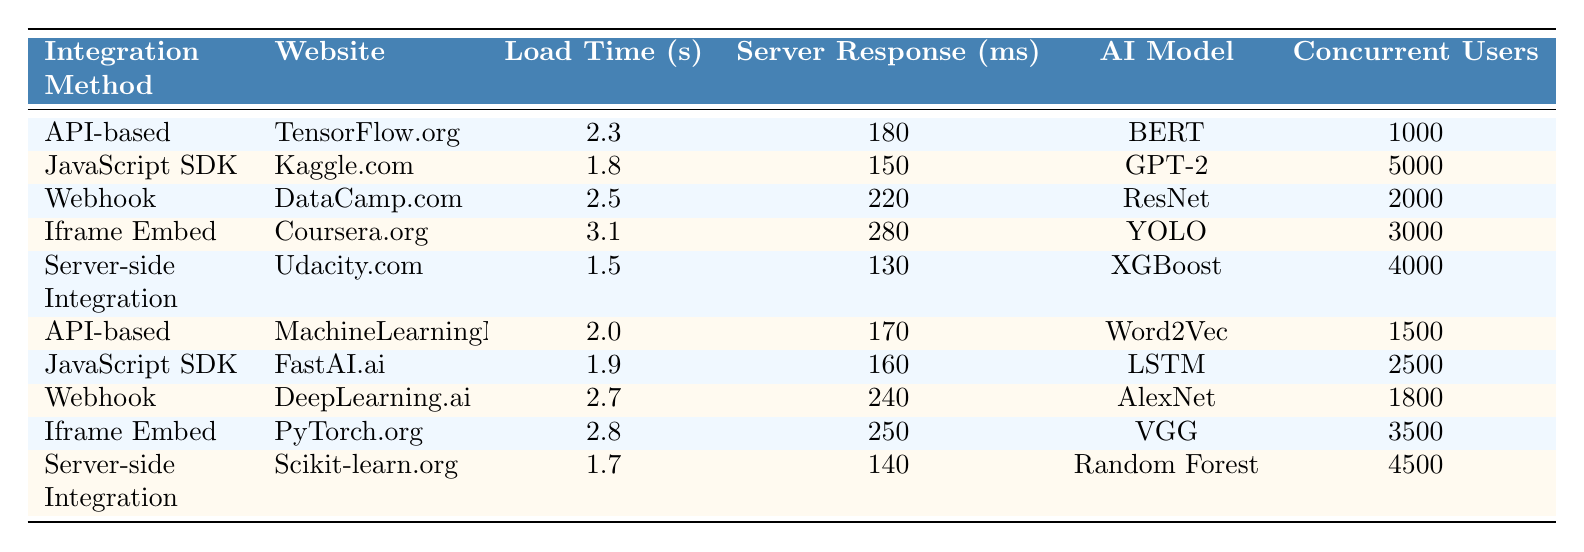What is the load time for Kaggle.com? The table shows that the load time for Kaggle.com is listed as 1.8 seconds under the "Load Time (s)" column.
Answer: 1.8 seconds Which integration method has the lowest server response time? By reviewing the "Server Response (ms)" column, the lowest value is 130 ms corresponding to the "Server-side Integration" method for Udacity.com.
Answer: Server-side Integration How many concurrent users can the API-based integration method support across all websites? There are two entries for "API-based," which are TensorFlow.org (1000 users) and MachineLearningMastery.com (1500 users). Adding these, 1000 + 1500 = 2500 users are supported.
Answer: 2500 users What is the average load time across all integration methods? To find the average load time, sum all the load times: 2.3 + 1.8 + 2.5 + 3.1 + 1.5 + 2.0 + 1.9 + 2.7 + 2.8 + 1.7 = 22.5 seconds. There are 10 data points, so the average is 22.5 / 10 = 2.25 seconds.
Answer: 2.25 seconds Is the website DeepLearning.ai using a Webhook integration slower than the average load time? The load time for DeepLearning.ai is 2.7 seconds. The average load time calculated previously is 2.25 seconds. Since 2.7 is greater than 2.25, it indicates that DeepLearning.ai's integration is slower than average.
Answer: Yes Which AI model has the highest server response time, and what is that time? Scanning the "Server Response (ms)" column, the highest value is 280 ms listed for the Iframe Embed method used by Coursera.org, which has the YOLO model.
Answer: YOLO, 280 ms How does the load time of server-side integration compare to that of Javascript SDK integration? The load time for server-side integration (1.5 seconds) is less than the load time for JavaScript SDK integration (1.8 seconds). Therefore, server-side integration is faster.
Answer: Server-side integration is faster Which integration method is associated with the most concurrent users? The "JavaScript SDK" for Kaggle.com supports 5000 concurrent users, which is the highest number listed in the "Concurrent Users" column.
Answer: JavaScript SDK What is the difference in server response time between the quickest and the slowest integration methods? The quickest server response time is 130 ms (Server-side Integration for Udacity.com) and the slowest is 280 ms (Iframe Embed for Coursera.org). The difference is 280 - 130 = 150 ms.
Answer: 150 ms Can a website using an Iframe Embed handle more concurrent users than one using Webhook? Iframe Embed (Coursera.org) supports 3000 concurrent users, while the Webhook method for both DataCamp.com (2000 users) and DeepLearning.ai (1800 users) support fewer users. Therefore, Iframe Embed can handle more concurrent users.
Answer: Yes What is the total load time for all websites utilizing the API-based integration method? The load times for API-based integration methods are 2.3 seconds (TensorFlow.org) and 2.0 seconds (MachineLearningMastery.com). Adding them together gives 2.3 + 2.0 = 4.3 seconds total.
Answer: 4.3 seconds 